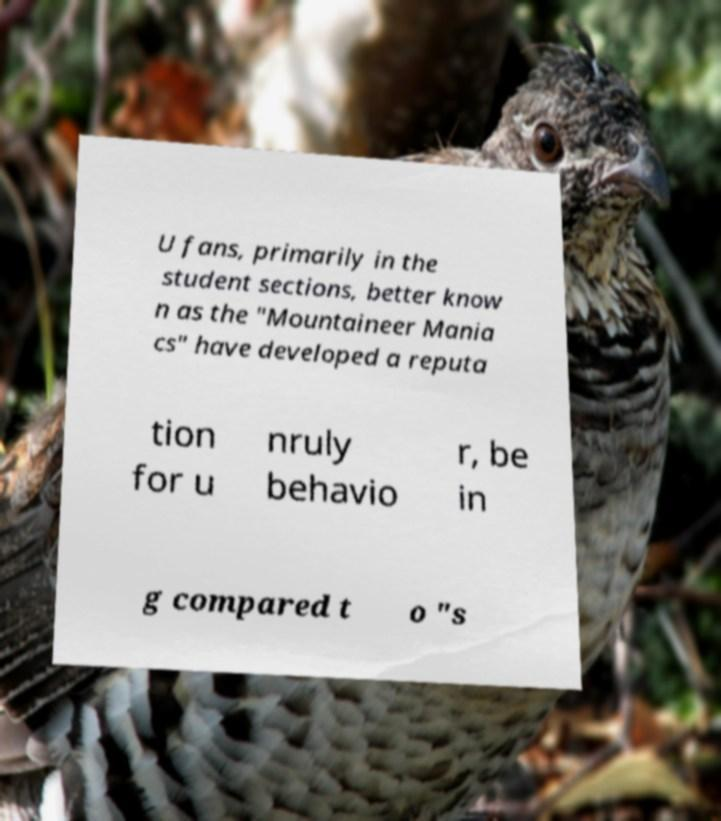I need the written content from this picture converted into text. Can you do that? U fans, primarily in the student sections, better know n as the "Mountaineer Mania cs" have developed a reputa tion for u nruly behavio r, be in g compared t o "s 